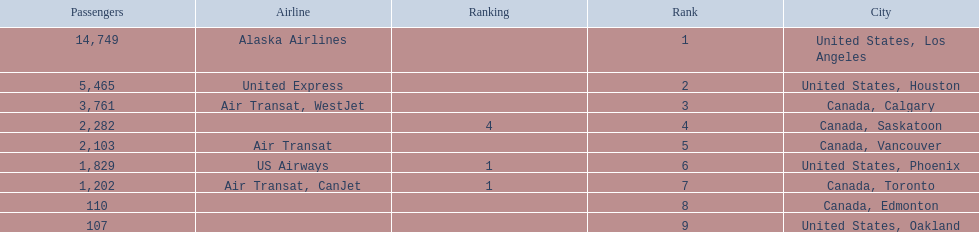What are the cities flown to? United States, Los Angeles, United States, Houston, Canada, Calgary, Canada, Saskatoon, Canada, Vancouver, United States, Phoenix, Canada, Toronto, Canada, Edmonton, United States, Oakland. What number of passengers did pheonix have? 1,829. 